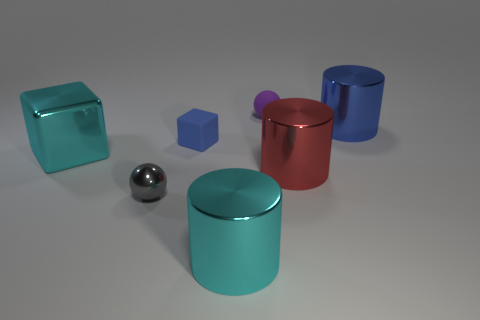Subtract all cyan cylinders. How many cylinders are left? 2 Add 1 tiny blue things. How many objects exist? 8 Subtract all cylinders. How many objects are left? 4 Add 6 small gray things. How many small gray things exist? 7 Subtract 0 purple blocks. How many objects are left? 7 Subtract all gray things. Subtract all gray metal things. How many objects are left? 5 Add 6 tiny things. How many tiny things are left? 9 